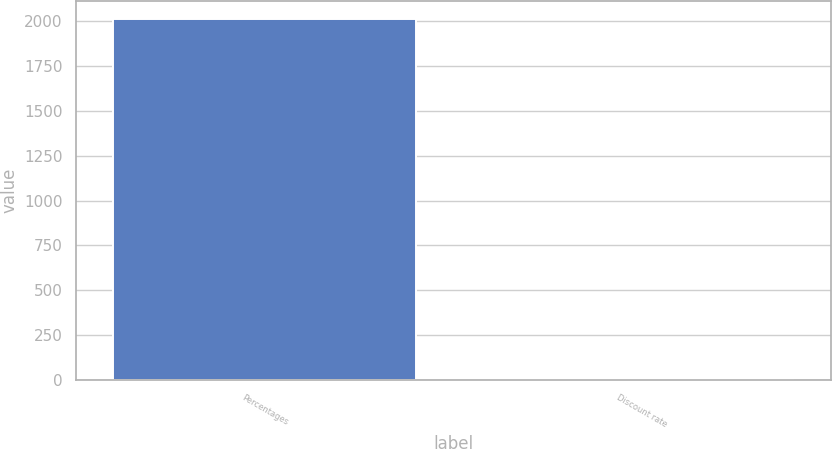Convert chart to OTSL. <chart><loc_0><loc_0><loc_500><loc_500><bar_chart><fcel>Percentages<fcel>Discount rate<nl><fcel>2014<fcel>4.47<nl></chart> 